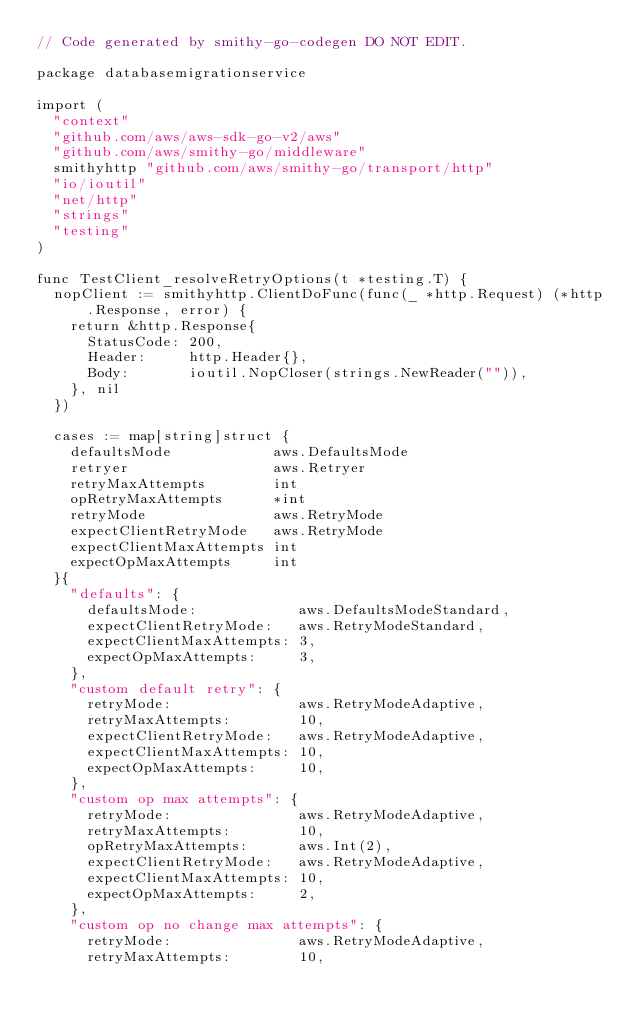Convert code to text. <code><loc_0><loc_0><loc_500><loc_500><_Go_>// Code generated by smithy-go-codegen DO NOT EDIT.

package databasemigrationservice

import (
	"context"
	"github.com/aws/aws-sdk-go-v2/aws"
	"github.com/aws/smithy-go/middleware"
	smithyhttp "github.com/aws/smithy-go/transport/http"
	"io/ioutil"
	"net/http"
	"strings"
	"testing"
)

func TestClient_resolveRetryOptions(t *testing.T) {
	nopClient := smithyhttp.ClientDoFunc(func(_ *http.Request) (*http.Response, error) {
		return &http.Response{
			StatusCode: 200,
			Header:     http.Header{},
			Body:       ioutil.NopCloser(strings.NewReader("")),
		}, nil
	})

	cases := map[string]struct {
		defaultsMode            aws.DefaultsMode
		retryer                 aws.Retryer
		retryMaxAttempts        int
		opRetryMaxAttempts      *int
		retryMode               aws.RetryMode
		expectClientRetryMode   aws.RetryMode
		expectClientMaxAttempts int
		expectOpMaxAttempts     int
	}{
		"defaults": {
			defaultsMode:            aws.DefaultsModeStandard,
			expectClientRetryMode:   aws.RetryModeStandard,
			expectClientMaxAttempts: 3,
			expectOpMaxAttempts:     3,
		},
		"custom default retry": {
			retryMode:               aws.RetryModeAdaptive,
			retryMaxAttempts:        10,
			expectClientRetryMode:   aws.RetryModeAdaptive,
			expectClientMaxAttempts: 10,
			expectOpMaxAttempts:     10,
		},
		"custom op max attempts": {
			retryMode:               aws.RetryModeAdaptive,
			retryMaxAttempts:        10,
			opRetryMaxAttempts:      aws.Int(2),
			expectClientRetryMode:   aws.RetryModeAdaptive,
			expectClientMaxAttempts: 10,
			expectOpMaxAttempts:     2,
		},
		"custom op no change max attempts": {
			retryMode:               aws.RetryModeAdaptive,
			retryMaxAttempts:        10,</code> 